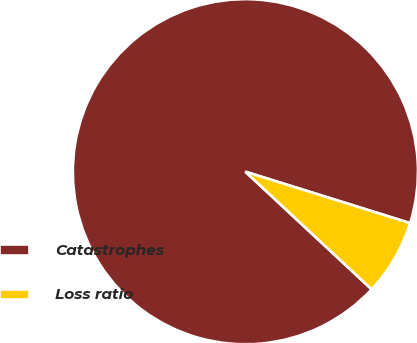Convert chart. <chart><loc_0><loc_0><loc_500><loc_500><pie_chart><fcel>Catastrophes<fcel>Loss ratio<nl><fcel>92.88%<fcel>7.12%<nl></chart> 